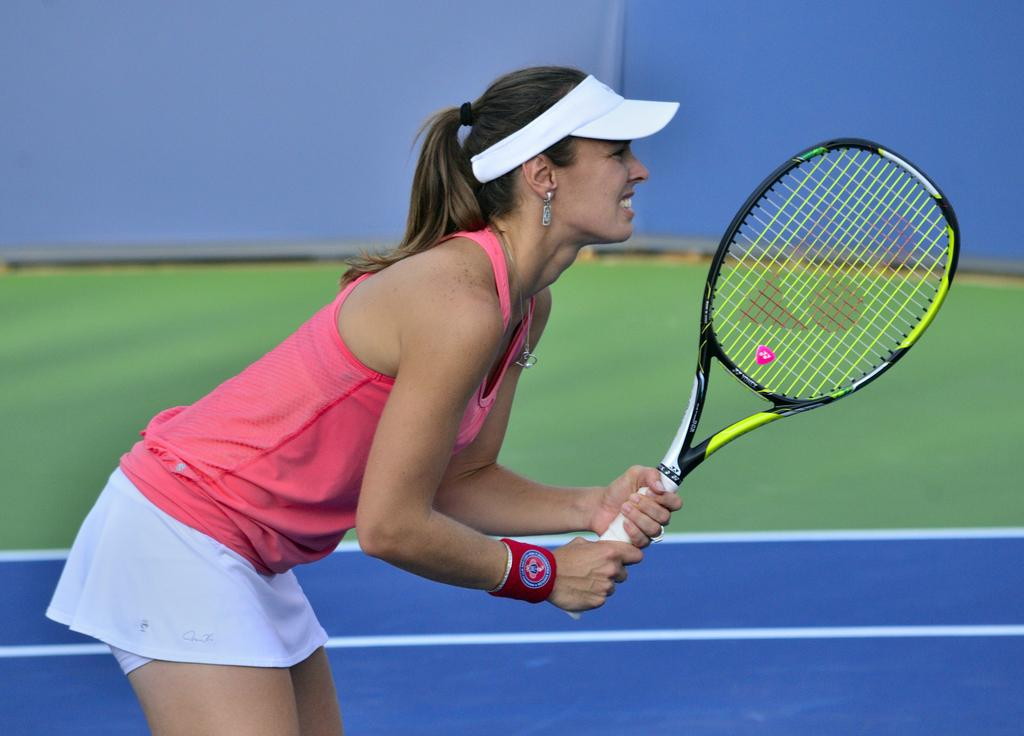What is the person in the image doing? The person is standing in the image and holding a bat. What can be seen in the background of the image? There is a wall in the background of the image. What type of secretary can be seen working at the desk in the image? There is no desk or secretary present in the image; it only features a person holding a bat and a wall in the background. 